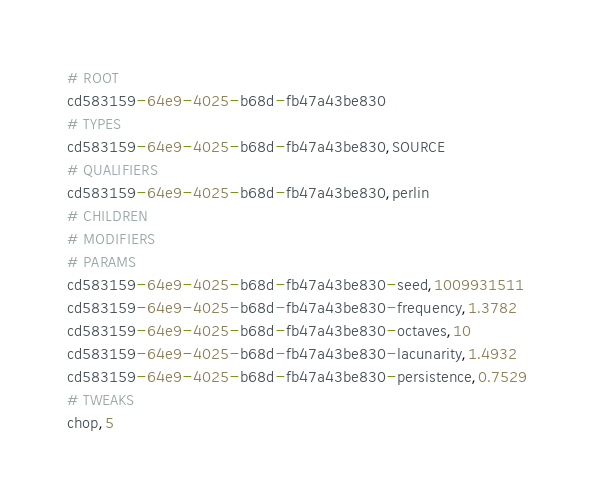<code> <loc_0><loc_0><loc_500><loc_500><_Nim_># ROOT
cd583159-64e9-4025-b68d-fb47a43be830
# TYPES
cd583159-64e9-4025-b68d-fb47a43be830,SOURCE
# QUALIFIERS
cd583159-64e9-4025-b68d-fb47a43be830,perlin
# CHILDREN
# MODIFIERS
# PARAMS
cd583159-64e9-4025-b68d-fb47a43be830-seed,1009931511
cd583159-64e9-4025-b68d-fb47a43be830-frequency,1.3782
cd583159-64e9-4025-b68d-fb47a43be830-octaves,10
cd583159-64e9-4025-b68d-fb47a43be830-lacunarity,1.4932
cd583159-64e9-4025-b68d-fb47a43be830-persistence,0.7529
# TWEAKS
chop,5</code> 